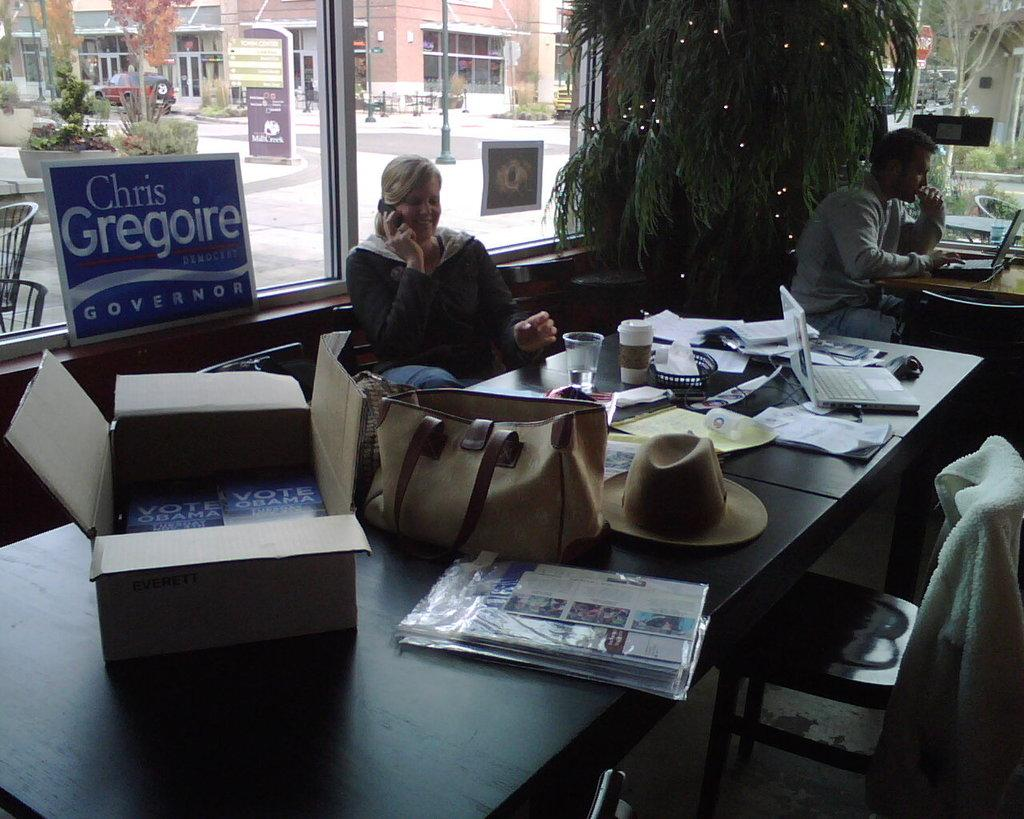What type of structure can be seen in the image? There is a building in the image. What seasonal decoration is present in the image? There is a Christmas tree in the image. What are the people in the image doing? The people are sitting on chairs in the image. What furniture is visible in the image? There is a table in the image. How many blades are visible on the Christmas tree in the image? There are no blades present on the Christmas tree in the image. What is the wealth of the people sitting on chairs in the image? The wealth of the people cannot be determined from the image. 